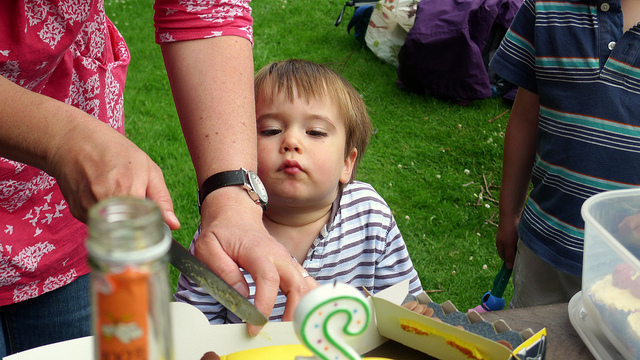Please extract the text content from this image. 2 